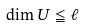<formula> <loc_0><loc_0><loc_500><loc_500>\dim U \leqq \ell</formula> 